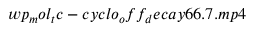Convert formula to latex. <formula><loc_0><loc_0><loc_500><loc_500>w p _ { m } o l _ { t } c - c y c l o _ { o } f f _ { d } e c a y 6 6 . 7 . m p 4</formula> 